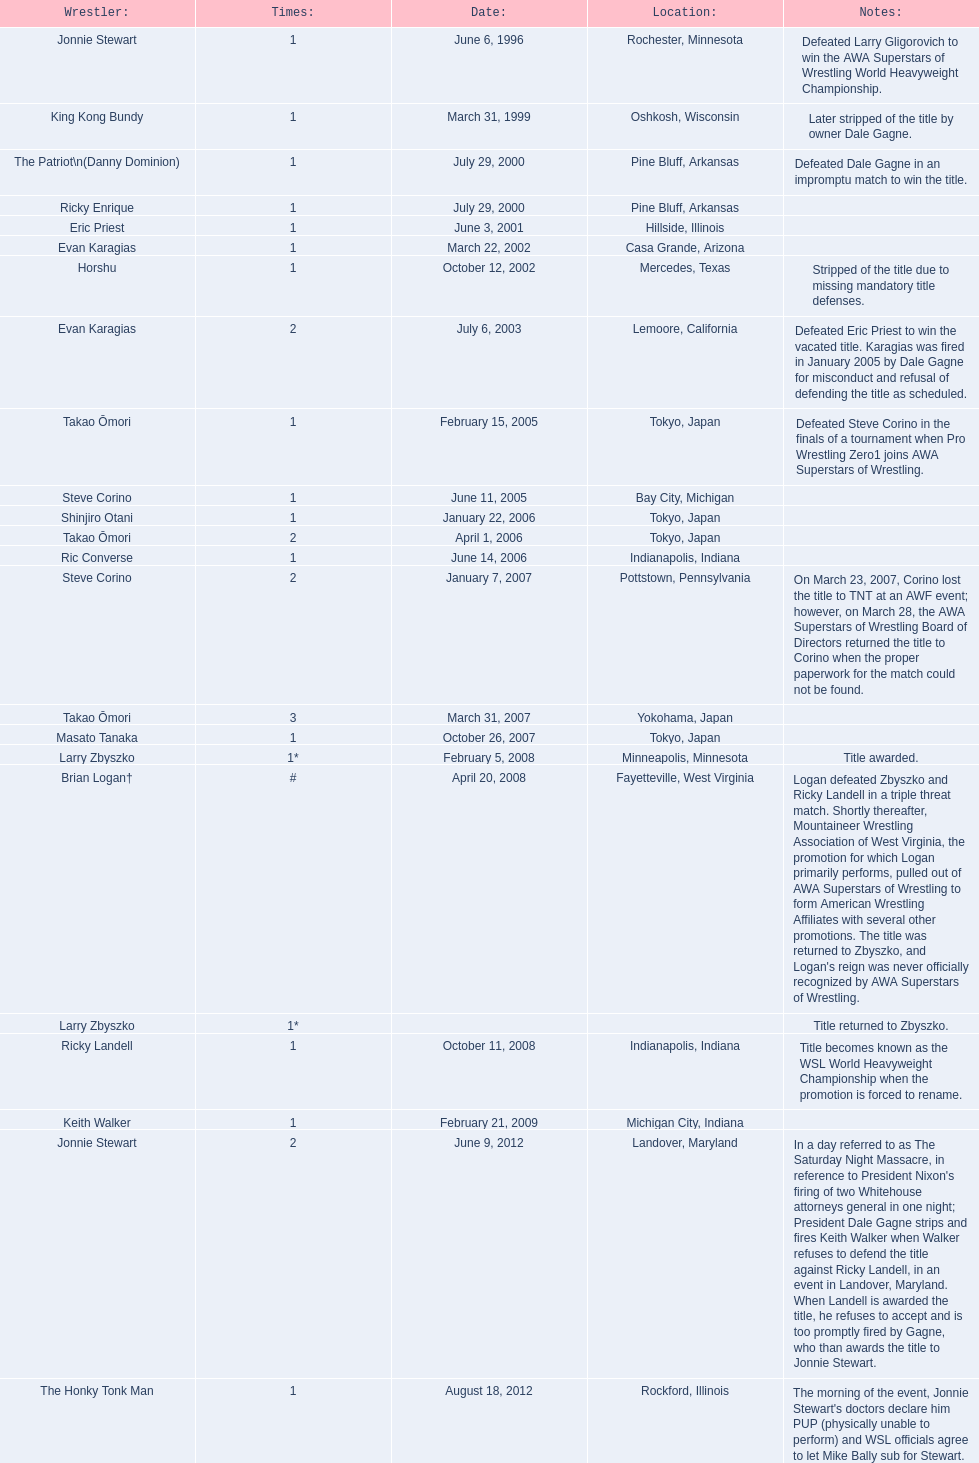Where are the championship holders from? Rochester, Minnesota, Oshkosh, Wisconsin, Pine Bluff, Arkansas, Pine Bluff, Arkansas, Hillside, Illinois, Casa Grande, Arizona, Mercedes, Texas, Lemoore, California, Tokyo, Japan, Bay City, Michigan, Tokyo, Japan, Tokyo, Japan, Indianapolis, Indiana, Pottstown, Pennsylvania, Yokohama, Japan, Tokyo, Japan, Minneapolis, Minnesota, Fayetteville, West Virginia, , Indianapolis, Indiana, Michigan City, Indiana, Landover, Maryland, Rockford, Illinois. Who is the championship holder from texas? Horshu. 